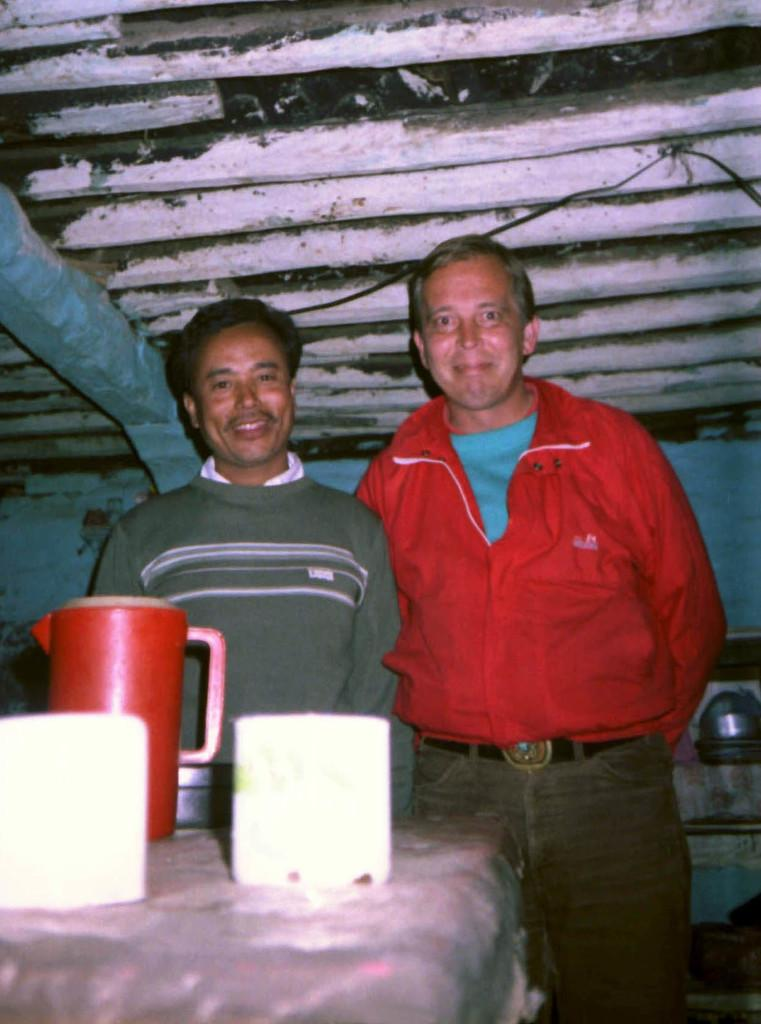What piece of furniture is present in the image? There is a table in the image. What is on the table? There is a water jug and other objects on the table. How many men are in the image? There are two men standing in the image. What structure can be seen at the top of the image? There is a shed visible at the top of the image. What type of oil can be seen being transported at the airport in the image? There is no airport or oil present in the image; it features a table, a water jug, objects, two men, and a shed. 